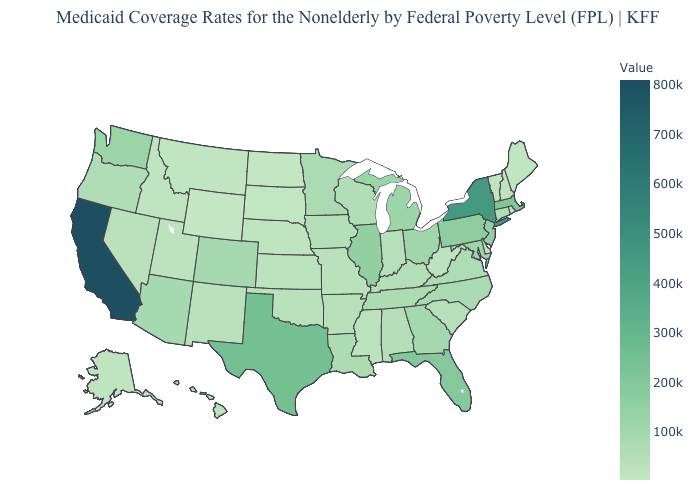Which states hav the highest value in the South?
Be succinct. Texas. Among the states that border New Hampshire , does Maine have the lowest value?
Answer briefly. Yes. Which states have the lowest value in the USA?
Short answer required. North Dakota. Does Arizona have a lower value than New York?
Give a very brief answer. Yes. Does Montana have a lower value than Texas?
Give a very brief answer. Yes. 